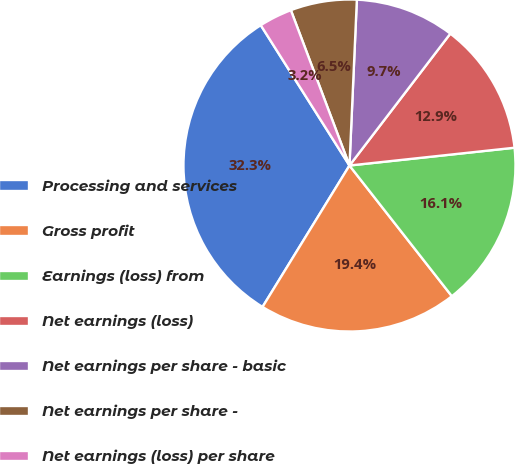Convert chart. <chart><loc_0><loc_0><loc_500><loc_500><pie_chart><fcel>Processing and services<fcel>Gross profit<fcel>Earnings (loss) from<fcel>Net earnings (loss)<fcel>Net earnings per share - basic<fcel>Net earnings per share -<fcel>Net earnings (loss) per share<nl><fcel>32.25%<fcel>19.35%<fcel>16.13%<fcel>12.9%<fcel>9.68%<fcel>6.45%<fcel>3.23%<nl></chart> 